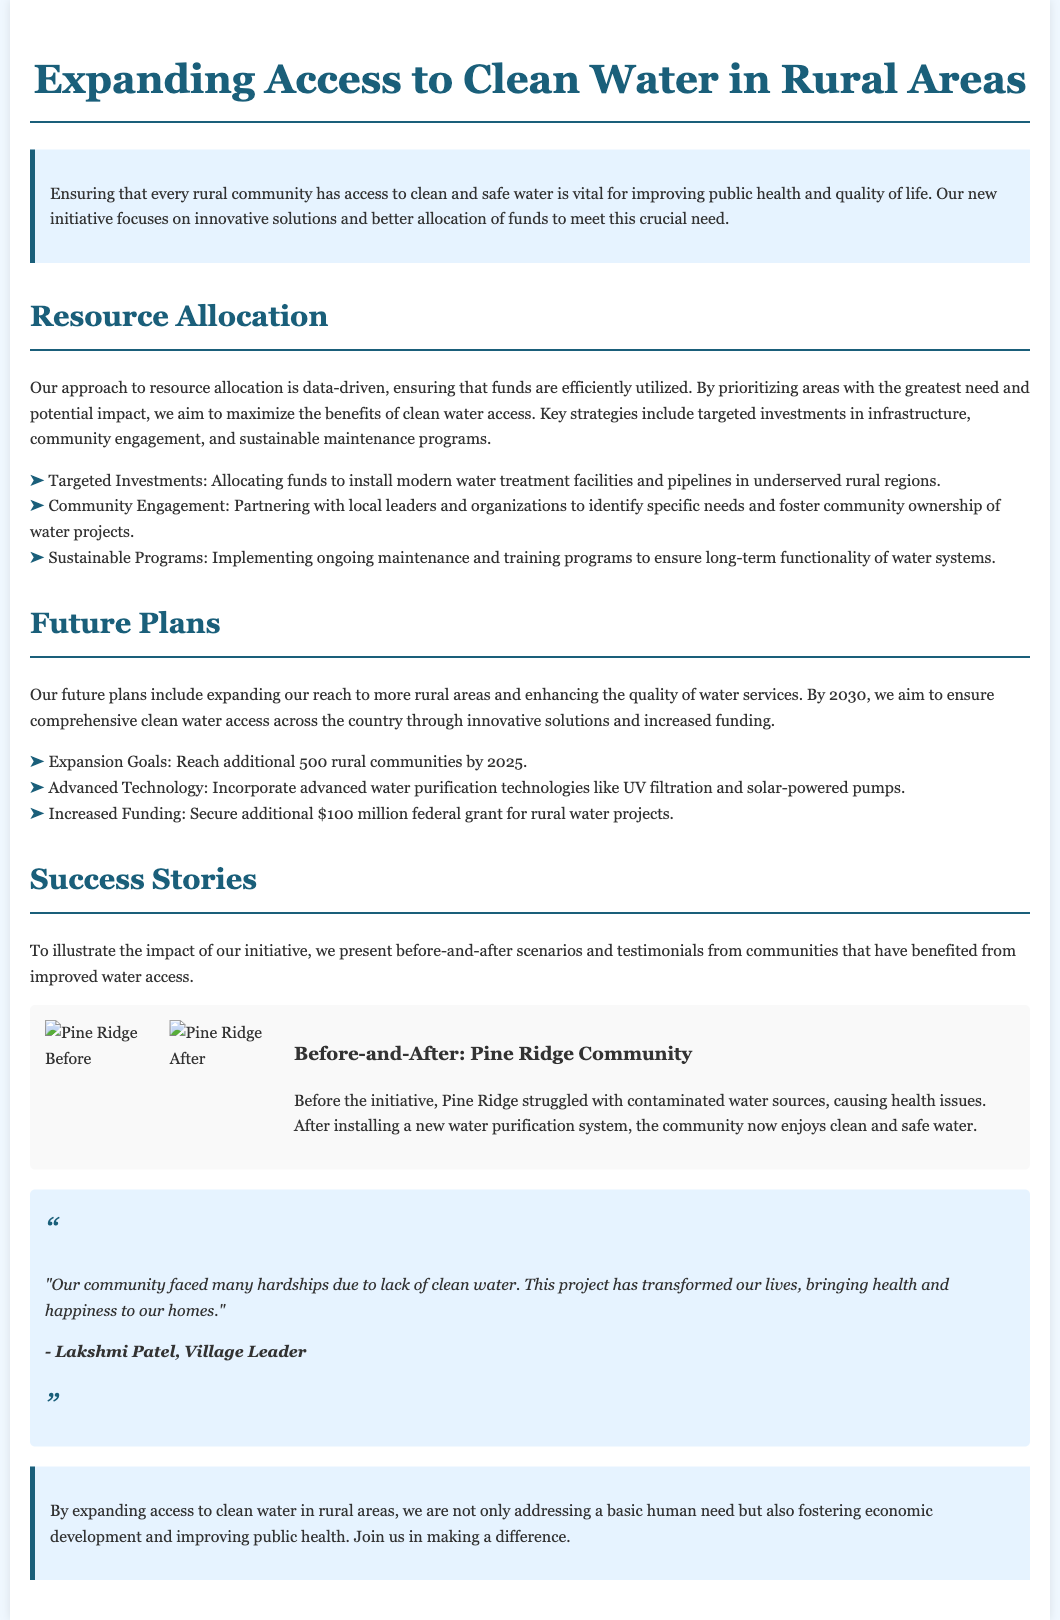What is the title of the initiative? The title of the initiative is prominently stated at the top of the document.
Answer: Expanding Access to Clean Water in Rural Areas What is one of the targeted investments for water access? This information can be found in the resource allocation section, which outlines specific initiatives.
Answer: Water treatment facilities How many rural communities do they aim to reach by 2025? This goal is mentioned in the future plans section of the document.
Answer: 500 Who is a village leader providing a testimonial? The document includes a quote from a community leader in the testimonial section.
Answer: Lakshmi Patel What year do they aim to achieve comprehensive clean water access by? The future plans section specifies a target year for achieving goals.
Answer: 2030 What technology is mentioned for water purification? The document discusses advanced technologies in the future plans section.
Answer: UV filtration What is the budget increase for rural water projects? This financial target is stated in the future plans section of the document.
Answer: $100 million What effect did the initiative have on Pine Ridge Community's water? The before-and-after section describes the transformation in water access.
Answer: Clean and safe water What type of photo is included in the success stories? The document specifies the use of visual aids in the success stories section.
Answer: Before-and-After Photos 